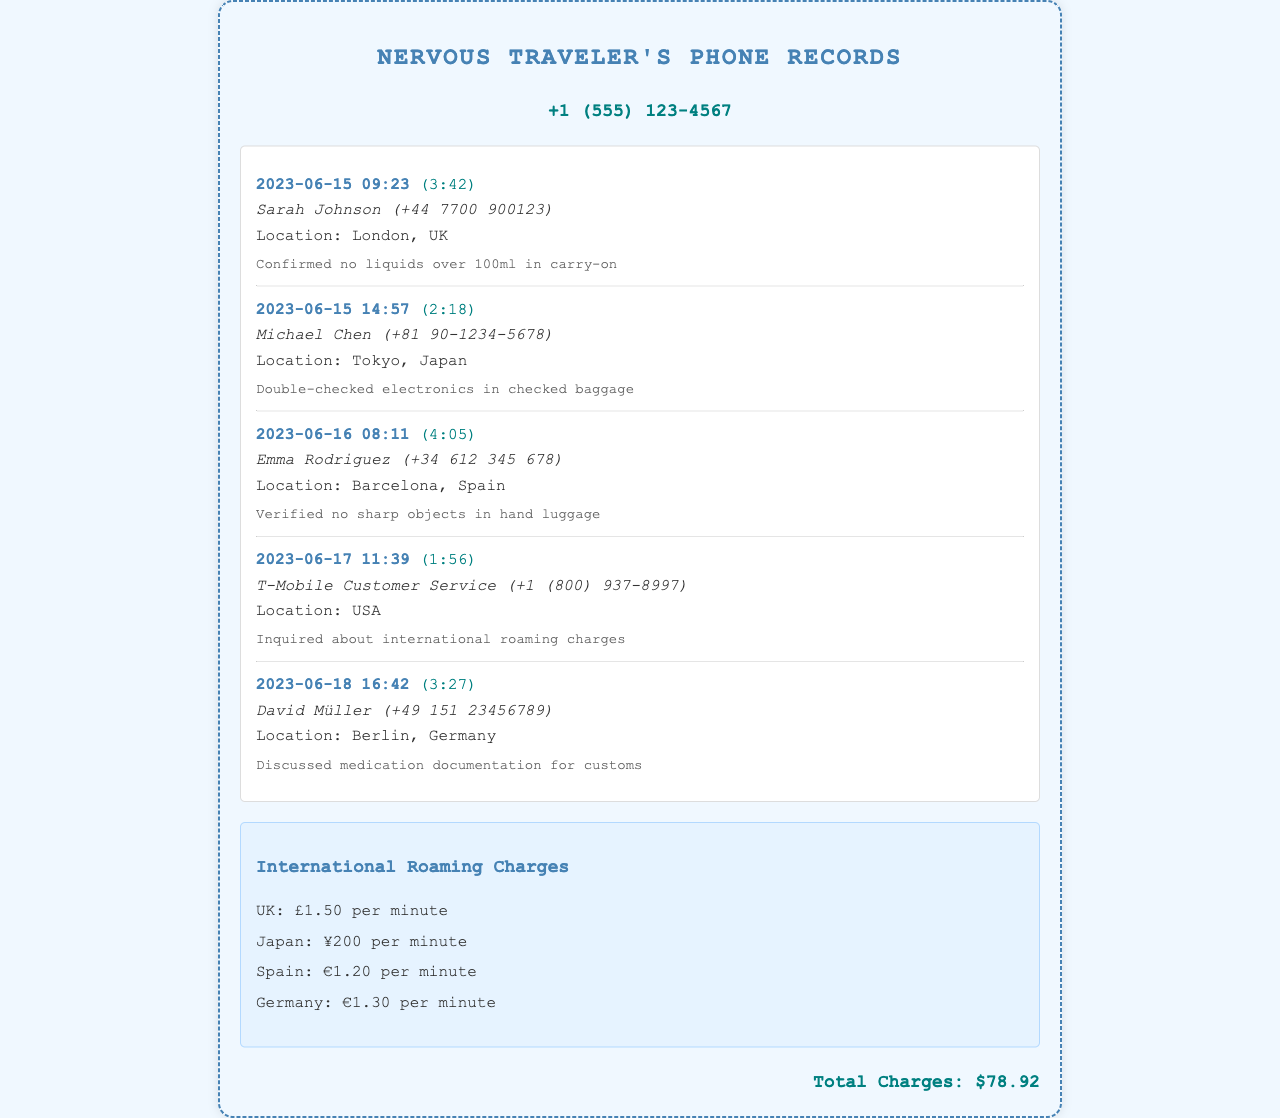What is the total charges? The total charges are explicitly stated in the document.
Answer: $78.92 Who did the traveler call in London? The call log lists the contact's name and location for the London call.
Answer: Sarah Johnson What was confirmed during the call with Sarah? The call notes mention a specific confirmation regarding carry-on items.
Answer: No liquids over 100ml in carry-on Which country had the highest per minute roaming charge? The roaming charges list shows the different rates for each country, allowing for comparison.
Answer: UK How long was the call to T-Mobile Customer Service? The duration of the call is included in the call log.
Answer: (1:56) What medications were discussed during the call with David? The call notes indicate the topic of the conversation with David.
Answer: Medication documentation for customs What is the roaming charge per minute in Japan? The roaming charges section provides specific rates for each country.
Answer: ¥200 per minute 